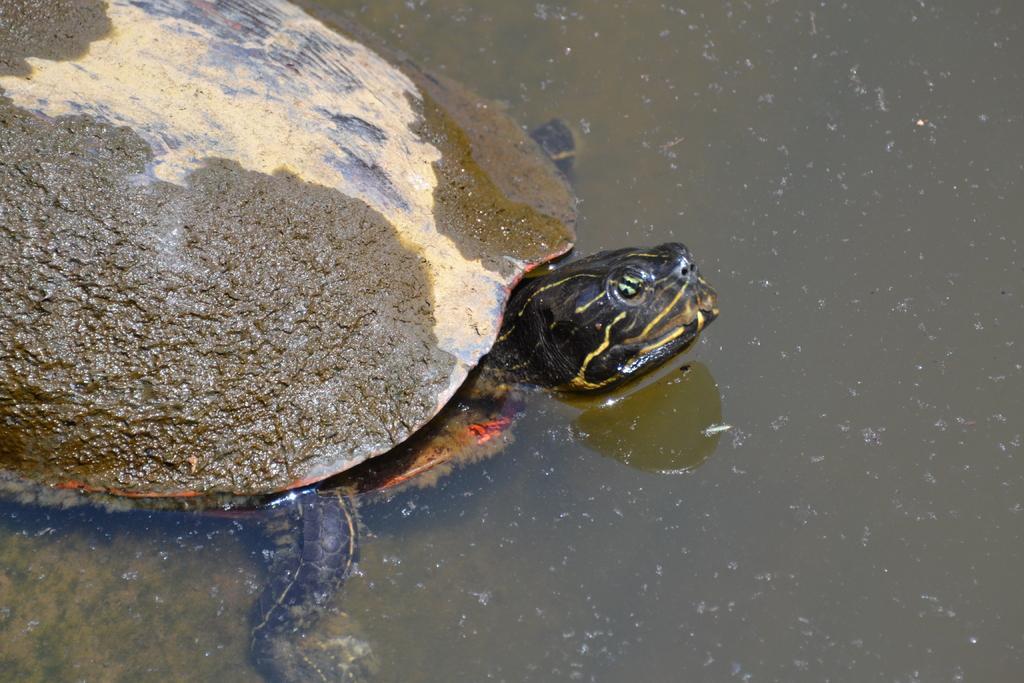Please provide a concise description of this image. In this picture we can see a tortoise in the water. 